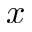<formula> <loc_0><loc_0><loc_500><loc_500>x</formula> 